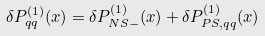Convert formula to latex. <formula><loc_0><loc_0><loc_500><loc_500>\delta P _ { q q } ^ { ( 1 ) } ( x ) = \delta P _ { N S - } ^ { ( 1 ) } ( x ) + \delta P _ { P S , q q } ^ { ( 1 ) } ( x )</formula> 